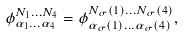<formula> <loc_0><loc_0><loc_500><loc_500>\phi _ { \alpha _ { 1 } \dots \alpha _ { 4 } } ^ { N _ { 1 } \dots N _ { 4 } } = \phi _ { \alpha _ { \sigma } ( 1 ) \dots \alpha _ { \sigma } ( 4 ) } ^ { N _ { \sigma } ( 1 ) \dots N _ { \sigma } ( 4 ) } ,</formula> 